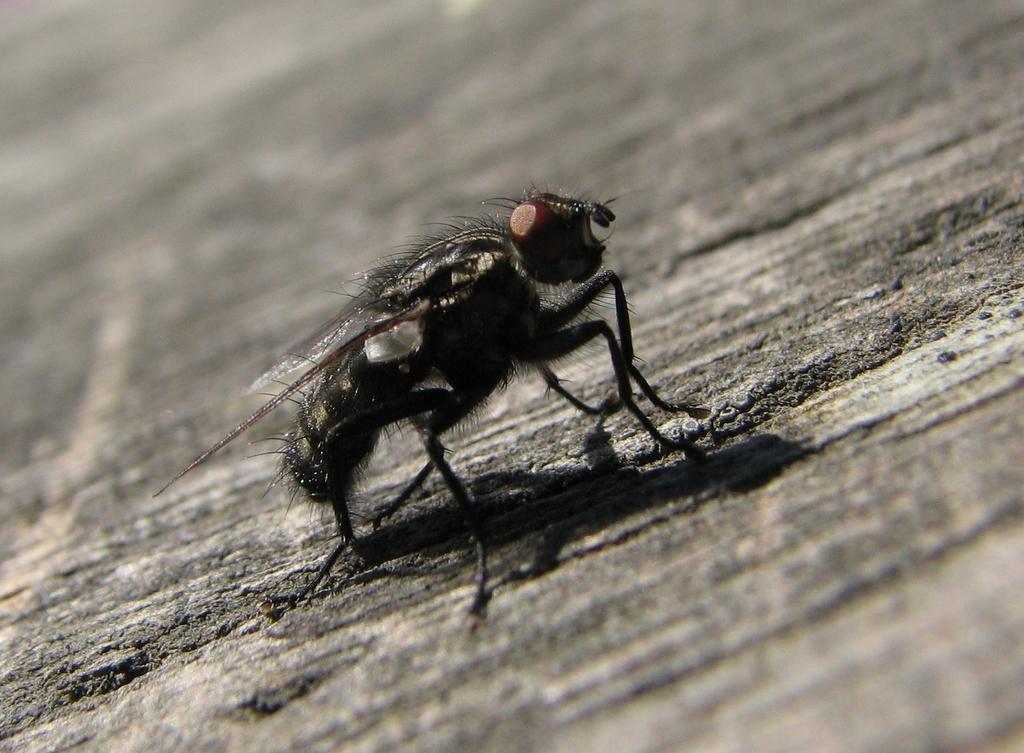Can you describe this image briefly? In this image I can see a black colour insect. I can also see this image is little bit blurry from background. 